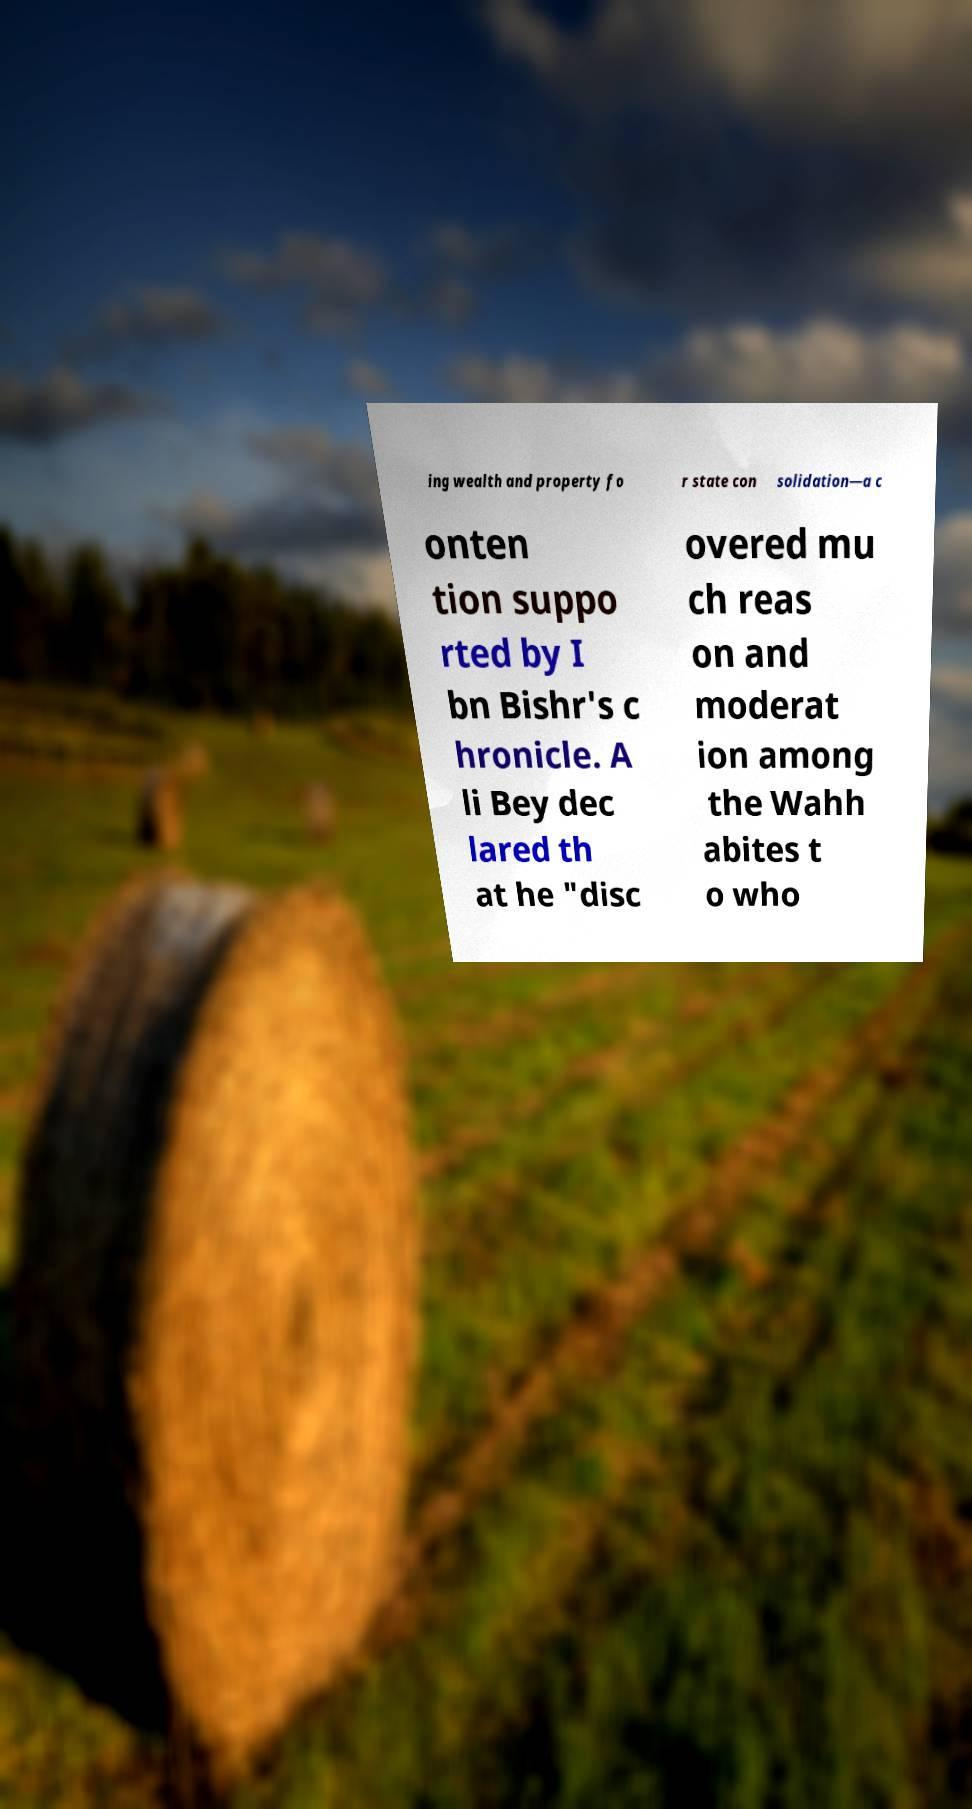Could you extract and type out the text from this image? ing wealth and property fo r state con solidation—a c onten tion suppo rted by I bn Bishr's c hronicle. A li Bey dec lared th at he "disc overed mu ch reas on and moderat ion among the Wahh abites t o who 